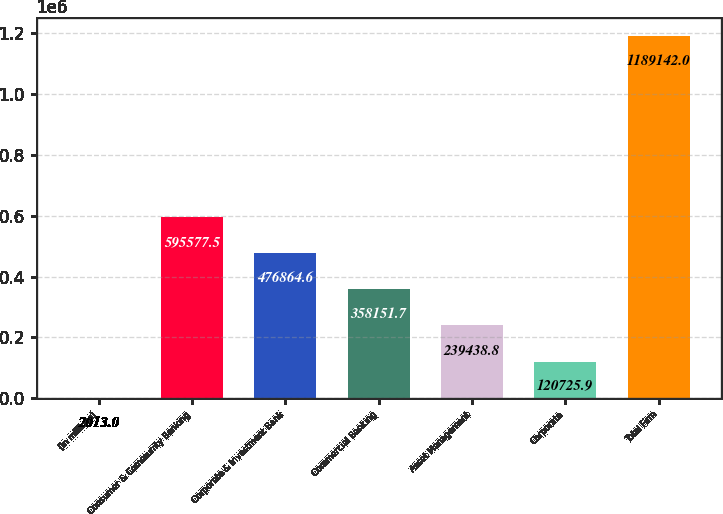Convert chart to OTSL. <chart><loc_0><loc_0><loc_500><loc_500><bar_chart><fcel>(in millions)<fcel>Consumer & Community Banking<fcel>Corporate & Investment Bank<fcel>Commercial Banking<fcel>Asset Management<fcel>Corporate<fcel>Total Firm<nl><fcel>2013<fcel>595578<fcel>476865<fcel>358152<fcel>239439<fcel>120726<fcel>1.18914e+06<nl></chart> 